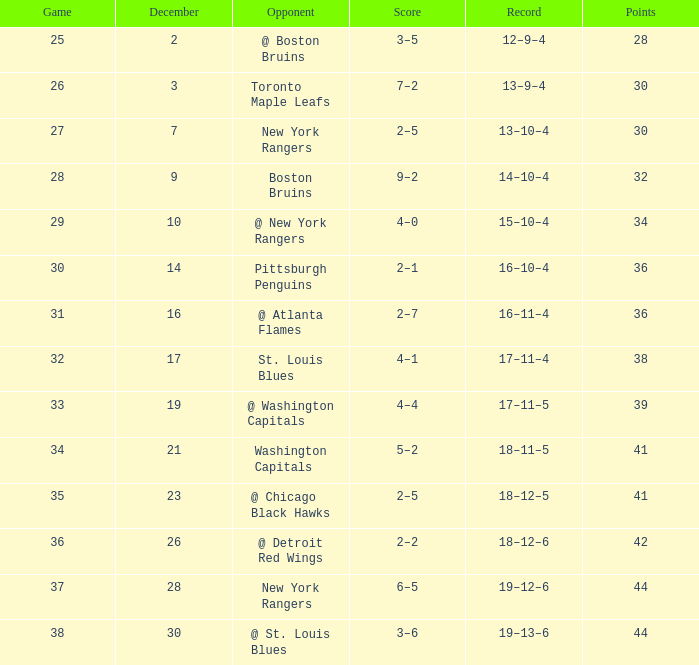In which game was the score 4-1? 32.0. 